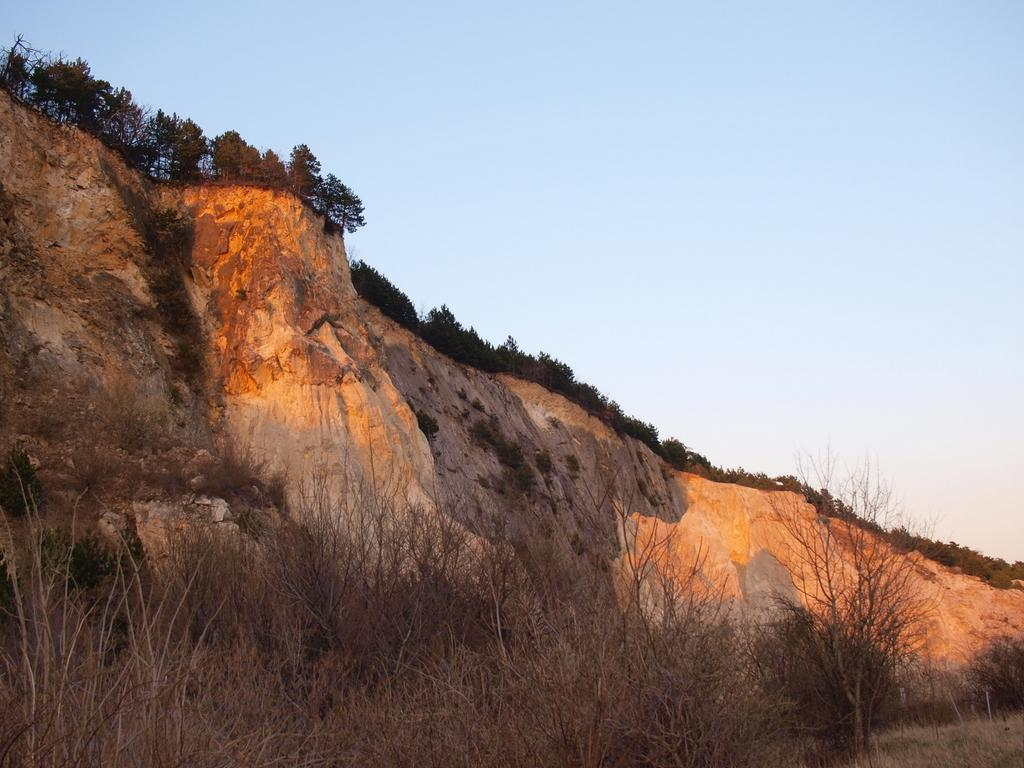What is the main feature of the image? There is a big rock mountain in the image. Are there any plants on the mountain? Yes, there are trees on top of the mountain. What type of vegetation can be seen at the bottom of the mountain? There are dried plants at the bottom of the mountain. Where is the crown placed on the mountain in the image? There is no crown present in the image. What type of toothpaste is used to clean the dried plants at the bottom of the mountain? There is no toothpaste mentioned or implied in the image, as it focuses on the mountain and its vegetation. 